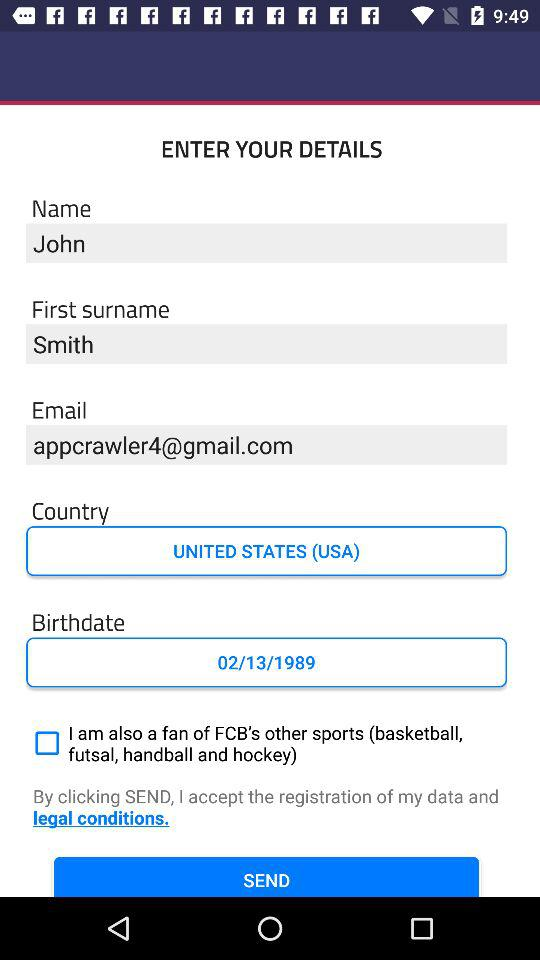What is the name? The name is John. 